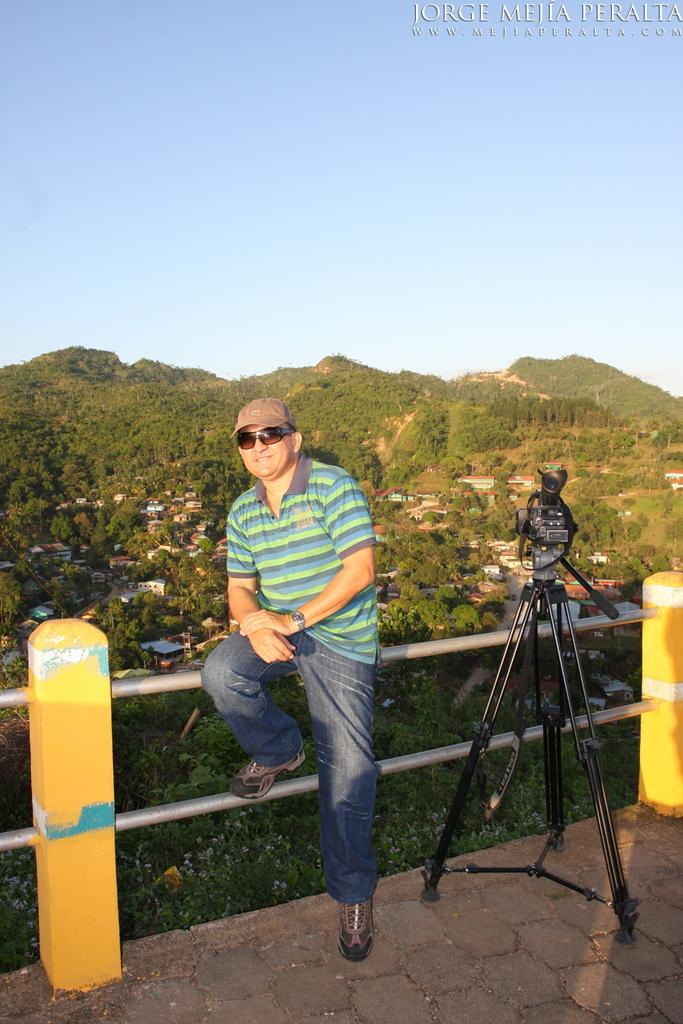What is the person in the image wearing on their head? The person is wearing a cap in the image. What type of eyewear is the person wearing? The person is wearing goggles in the image. What type of clothing is the person wearing on their upper body? The person is wearing a t-shirt in the image. What type of clothing is the person wearing on their lower body? The person is wearing jeans in the image. What equipment can be seen at the right side of the image? There is a tripod at the right side of the image. What activity might the person be engaged in, based on the presence of the tripod? The person might be engaged in photography or videography, as tripods are commonly used for these activities. What type of structure is visible in the image? There is a building in the image. What type of natural environment is visible in the image? There are trees and hills in the image. What type of garden can be seen in the image? There is no garden present in the image. 